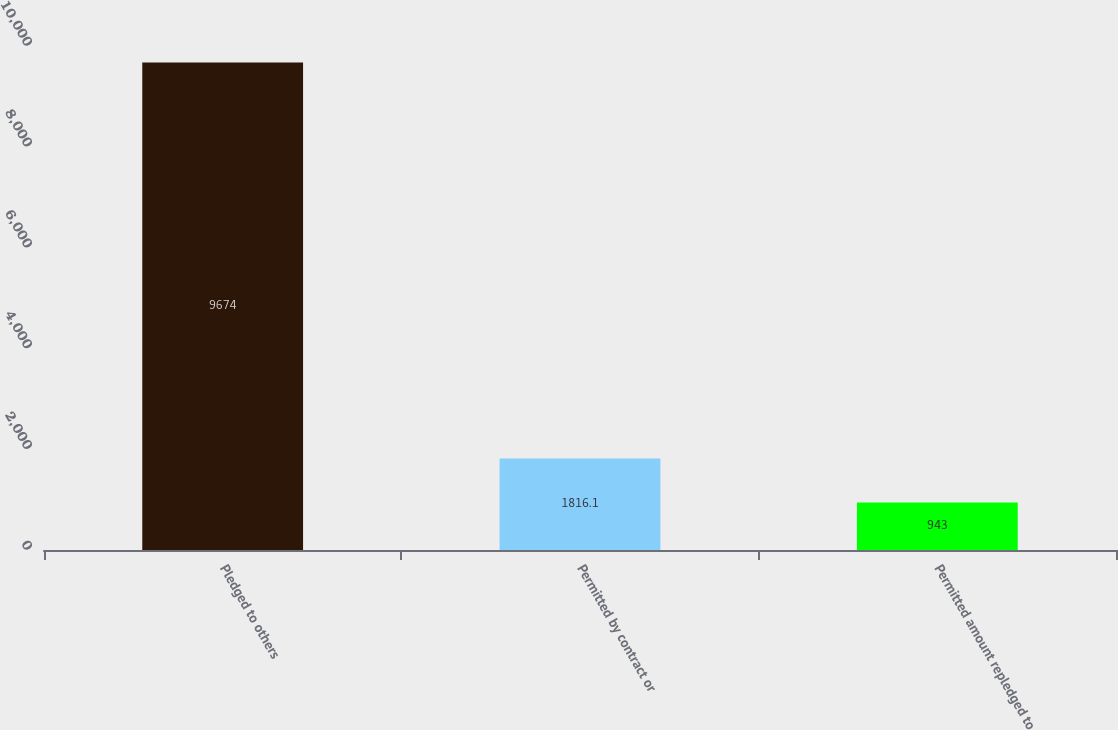Convert chart. <chart><loc_0><loc_0><loc_500><loc_500><bar_chart><fcel>Pledged to others<fcel>Permitted by contract or<fcel>Permitted amount repledged to<nl><fcel>9674<fcel>1816.1<fcel>943<nl></chart> 